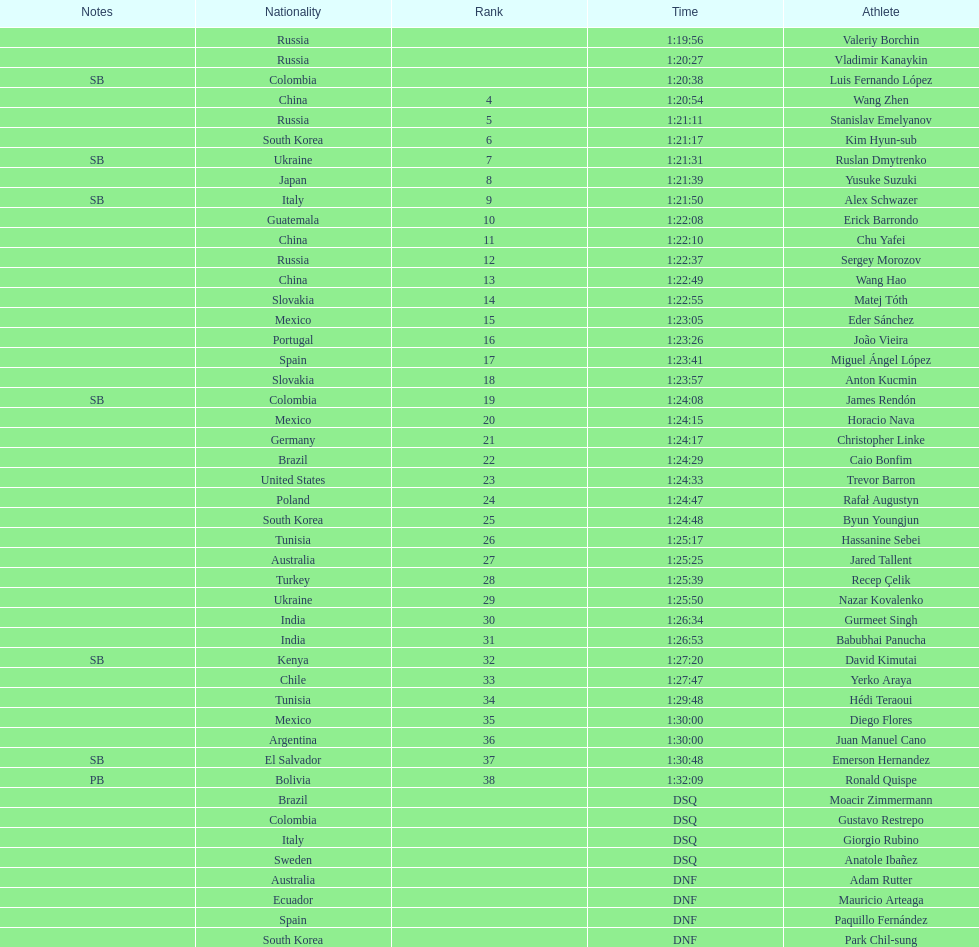What is the total count of athletes included in the rankings chart, including those classified as dsq & dnf? 46. 